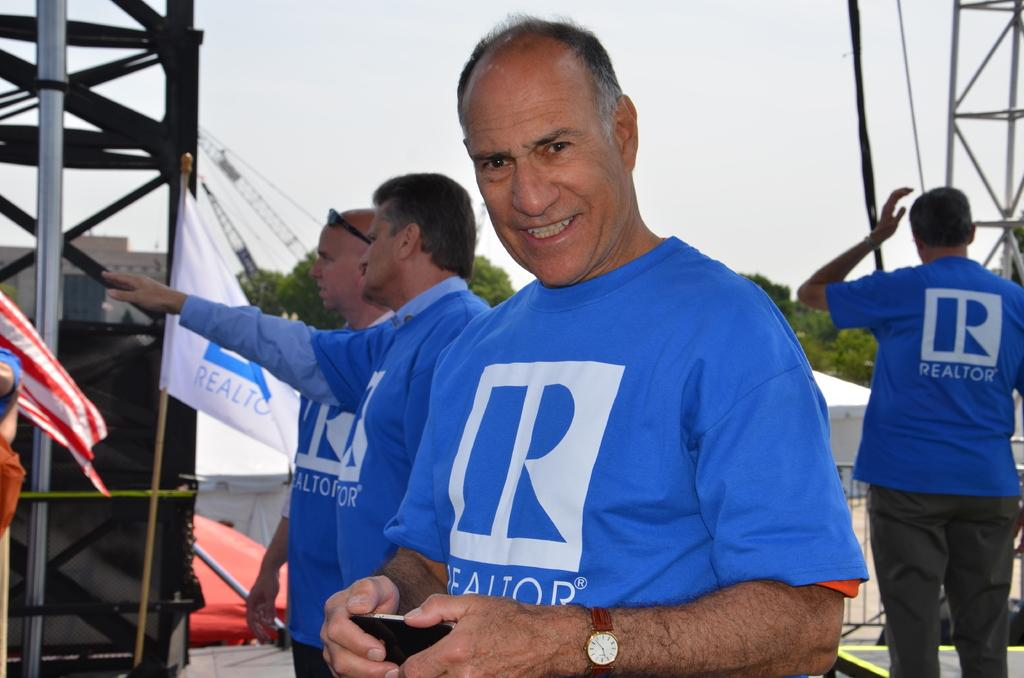<image>
Present a compact description of the photo's key features. a man grinning in a Realtor shirt standing near others in the same shirt 